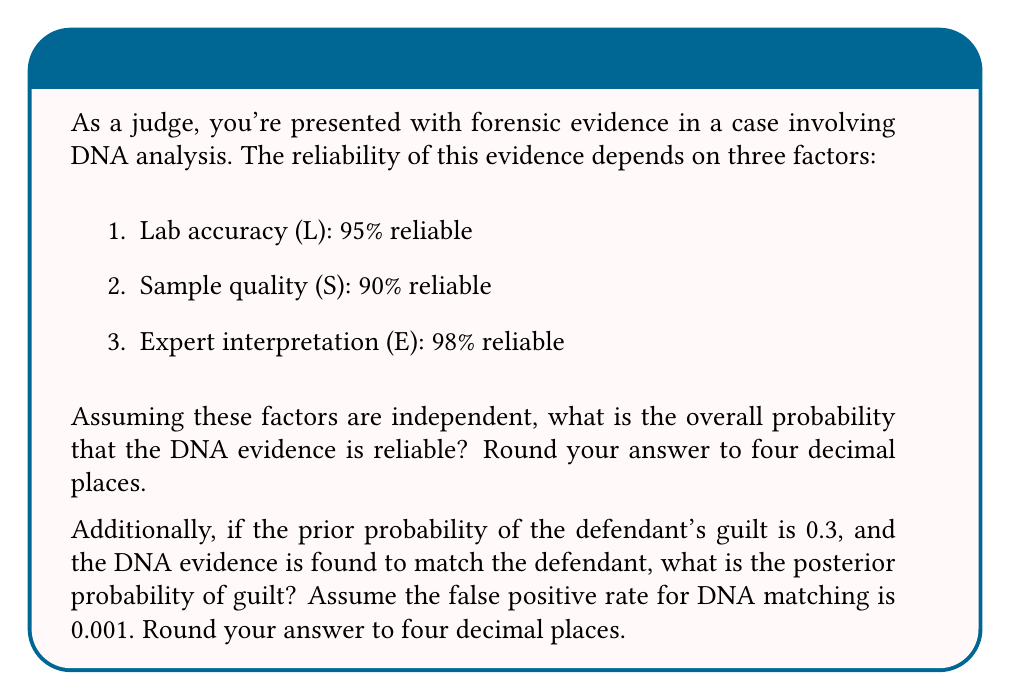Help me with this question. To solve this problem, we'll use Bayesian probability concepts:

1. Overall reliability of DNA evidence:
   The probability that all three factors are reliable is the product of their individual probabilities:

   $$P(Reliable) = P(L) \times P(S) \times P(E)$$
   $$P(Reliable) = 0.95 \times 0.90 \times 0.98 = 0.8379$$

   Rounded to four decimal places: 0.8379

2. Posterior probability of guilt:
   We'll use Bayes' theorem:

   $$P(G|E) = \frac{P(E|G) \times P(G)}{P(E)}$$

   Where:
   - $P(G|E)$ is the posterior probability of guilt given the evidence
   - $P(E|G)$ is the probability of the evidence given guilt (sensitivity)
   - $P(G)$ is the prior probability of guilt
   - $P(E)$ is the total probability of the evidence

   We know:
   - $P(G) = 0.3$ (prior probability of guilt)
   - $P(E|G) = 0.8379$ (reliability of the DNA evidence)
   - $P(E|\neg G) = 0.001$ (false positive rate)

   Calculate $P(E)$:
   $$P(E) = P(E|G) \times P(G) + P(E|\neg G) \times P(\neg G)$$
   $$P(E) = 0.8379 \times 0.3 + 0.001 \times 0.7 = 0.25207$$

   Now apply Bayes' theorem:
   $$P(G|E) = \frac{0.8379 \times 0.3}{0.25207} = 0.9970$$

   Rounded to four decimal places: 0.9970
Answer: 0.8379, 0.9970 